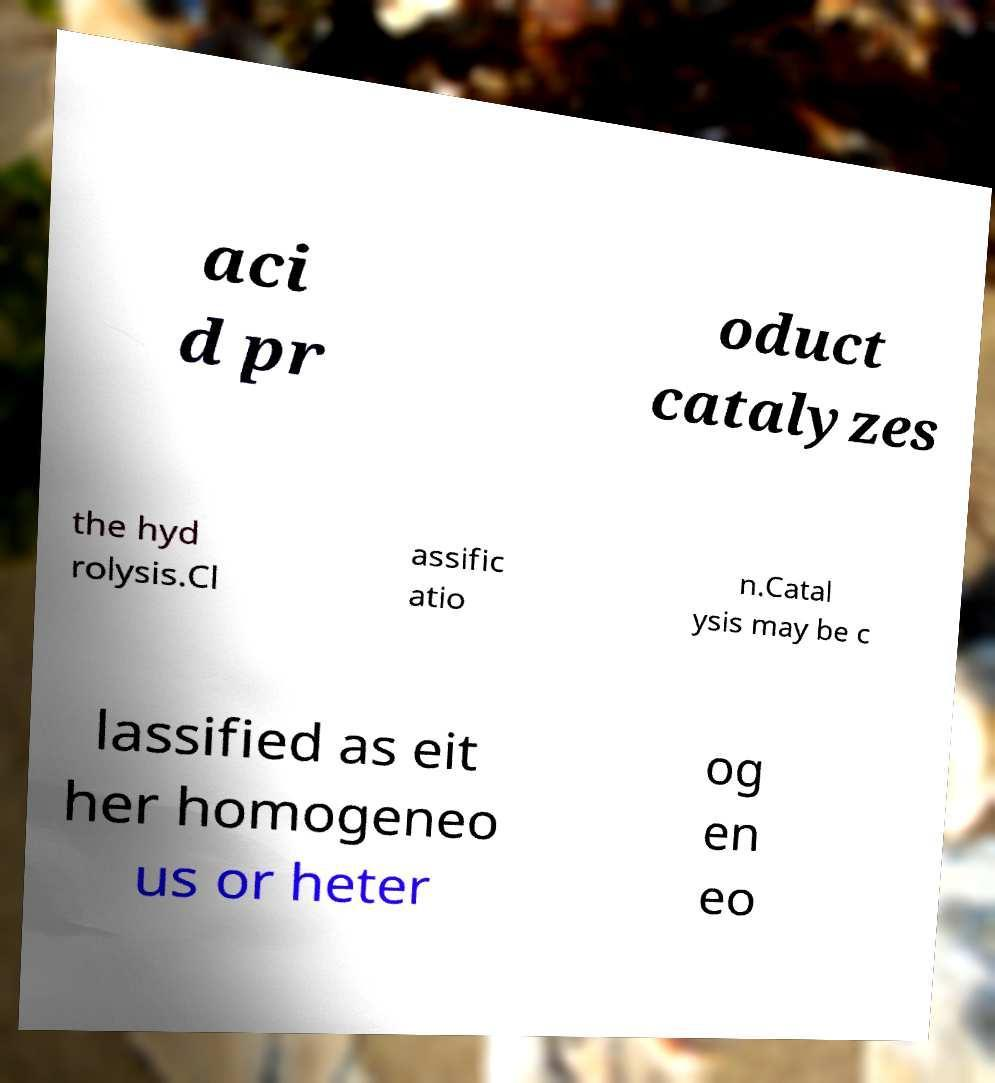What messages or text are displayed in this image? I need them in a readable, typed format. aci d pr oduct catalyzes the hyd rolysis.Cl assific atio n.Catal ysis may be c lassified as eit her homogeneo us or heter og en eo 